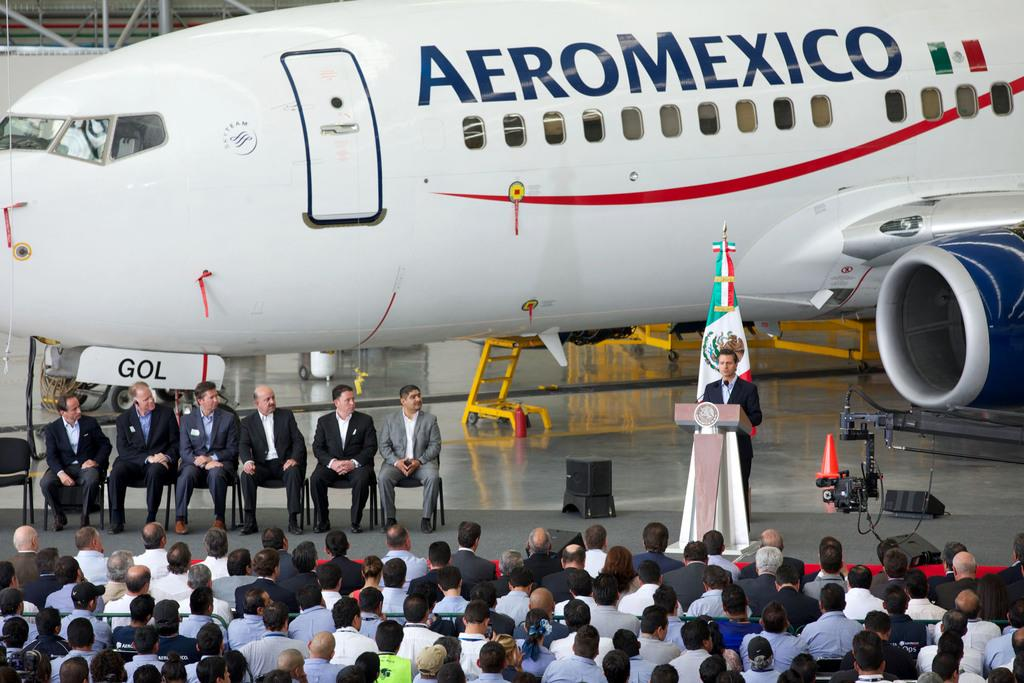<image>
Render a clear and concise summary of the photo. A man is in front of a group of people with a jet with the name AeroMexico in the background 